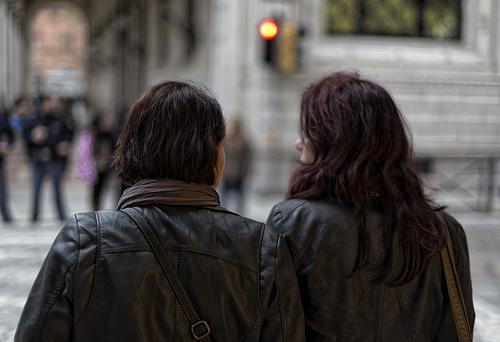Question: where was the photo taken?
Choices:
A. On a boat.
B. At the zoo.
C. In the car.
D. On the sidewalk.
Answer with the letter. Answer: D Question: what is black?
Choices:
A. The coats.
B. The shoes.
C. The shirts.
D. The pants.
Answer with the letter. Answer: A Question: what are the woman holding?
Choices:
A. Bags.
B. Coats.
C. Hats.
D. Shoes.
Answer with the letter. Answer: A Question: how many women are there?
Choices:
A. 2.
B. 7.
C. 6.
D. 5.
Answer with the letter. Answer: A Question: what are the woman doing?
Choices:
A. Running.
B. Walking.
C. Laughing.
D. Talking.
Answer with the letter. Answer: B 